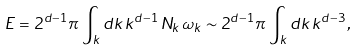Convert formula to latex. <formula><loc_0><loc_0><loc_500><loc_500>E = 2 ^ { d - 1 } \pi \, \int _ { k } d k \, k ^ { d - 1 } \, N _ { k } \, \omega _ { k } \sim 2 ^ { d - 1 } \pi \, \int _ { k } d k \, k ^ { d - 3 } \, ,</formula> 